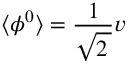Convert formula to latex. <formula><loc_0><loc_0><loc_500><loc_500>\langle \phi ^ { 0 } \rangle = { \frac { 1 } { \sqrt { 2 \, } } } v</formula> 